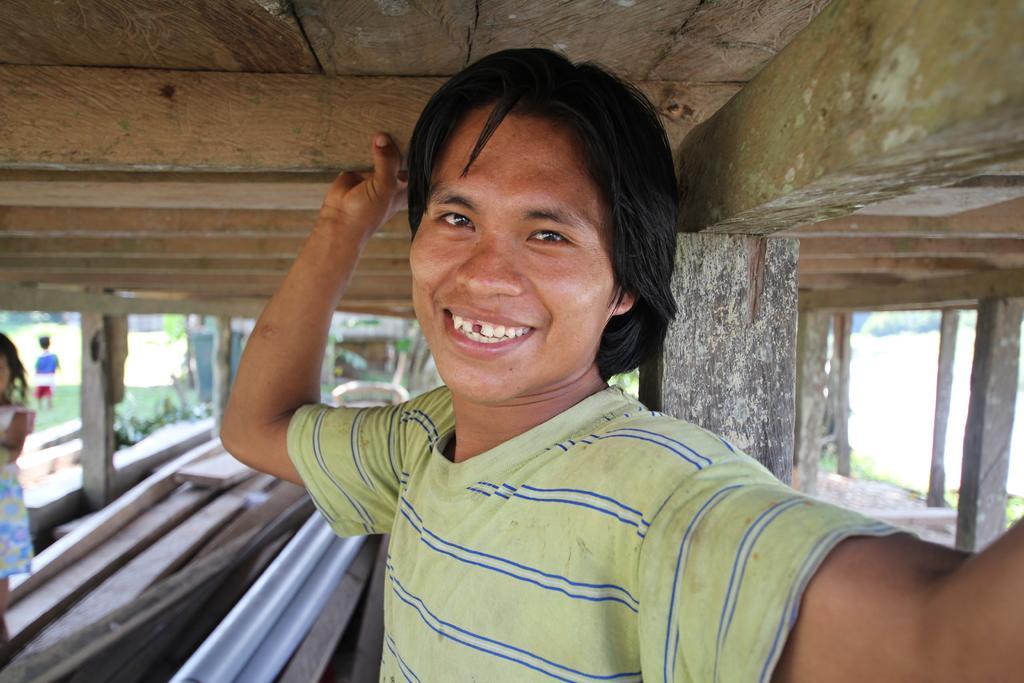Can you describe this image briefly? In this image we can see a person and the person is holding a wooden object. Behind the person we can see a wooden object. On the left side, we can see two persons and plants. On the right side, we can see wooden objects and plants. At the top we can see the wooden roof. 